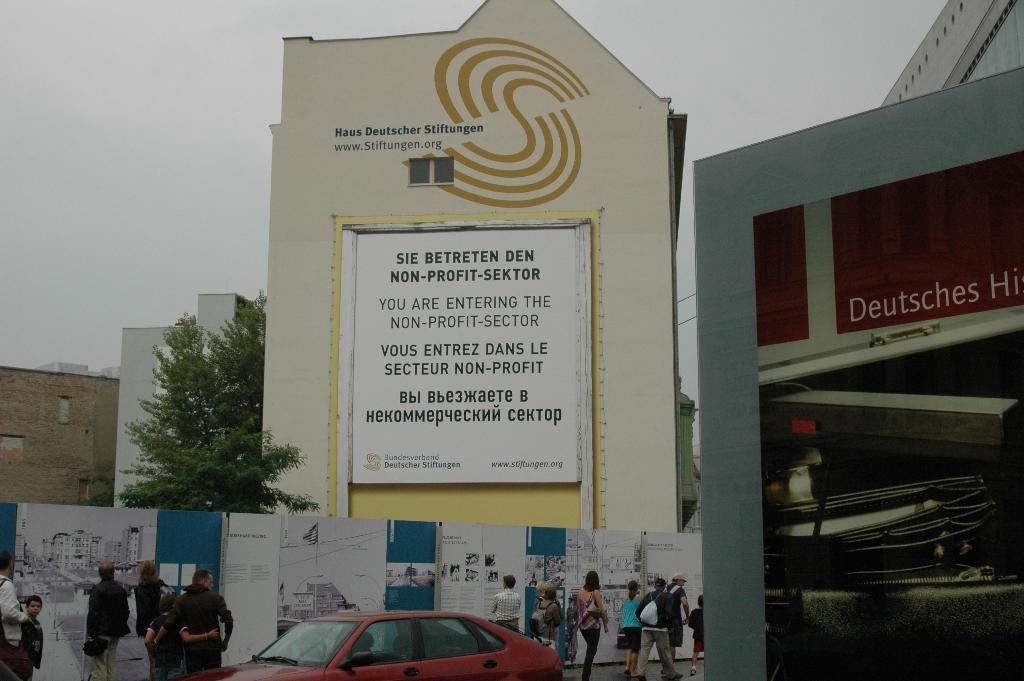What is the main subject of the image? The main subject of the image is a car. Are there any people present in the image? Yes, there are people in the image. What can be seen on the wall in the image? There are banners on the wall in the image. What type of natural elements are present in the image? There are trees in the image. What type of structures can be seen in the image? There are buildings in the image. What is visible in the background of the image? The sky is visible in the background of the image. What type of vegetable is being used as a decoration on the car in the image? There is no vegetable present on the car in the image. What type of brass instrument is being played by the people in the image? There is no brass instrument being played by the people in the image. 